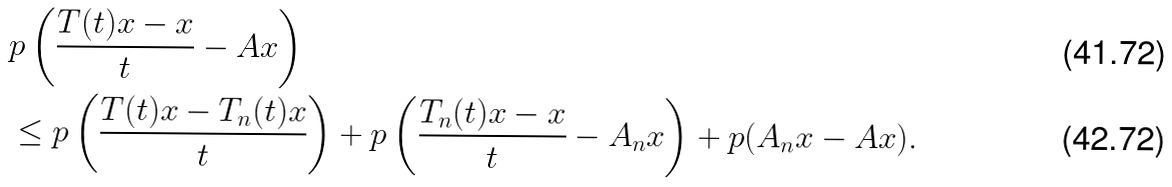<formula> <loc_0><loc_0><loc_500><loc_500>& p \left ( \frac { T ( t ) x - x } { t } - A x \right ) \\ & \leq p \left ( \frac { T ( t ) x - T _ { n } ( t ) x } { t } \right ) + p \left ( \frac { T _ { n } ( t ) x - x } { t } - A _ { n } x \right ) + p ( A _ { n } x - A x ) .</formula> 